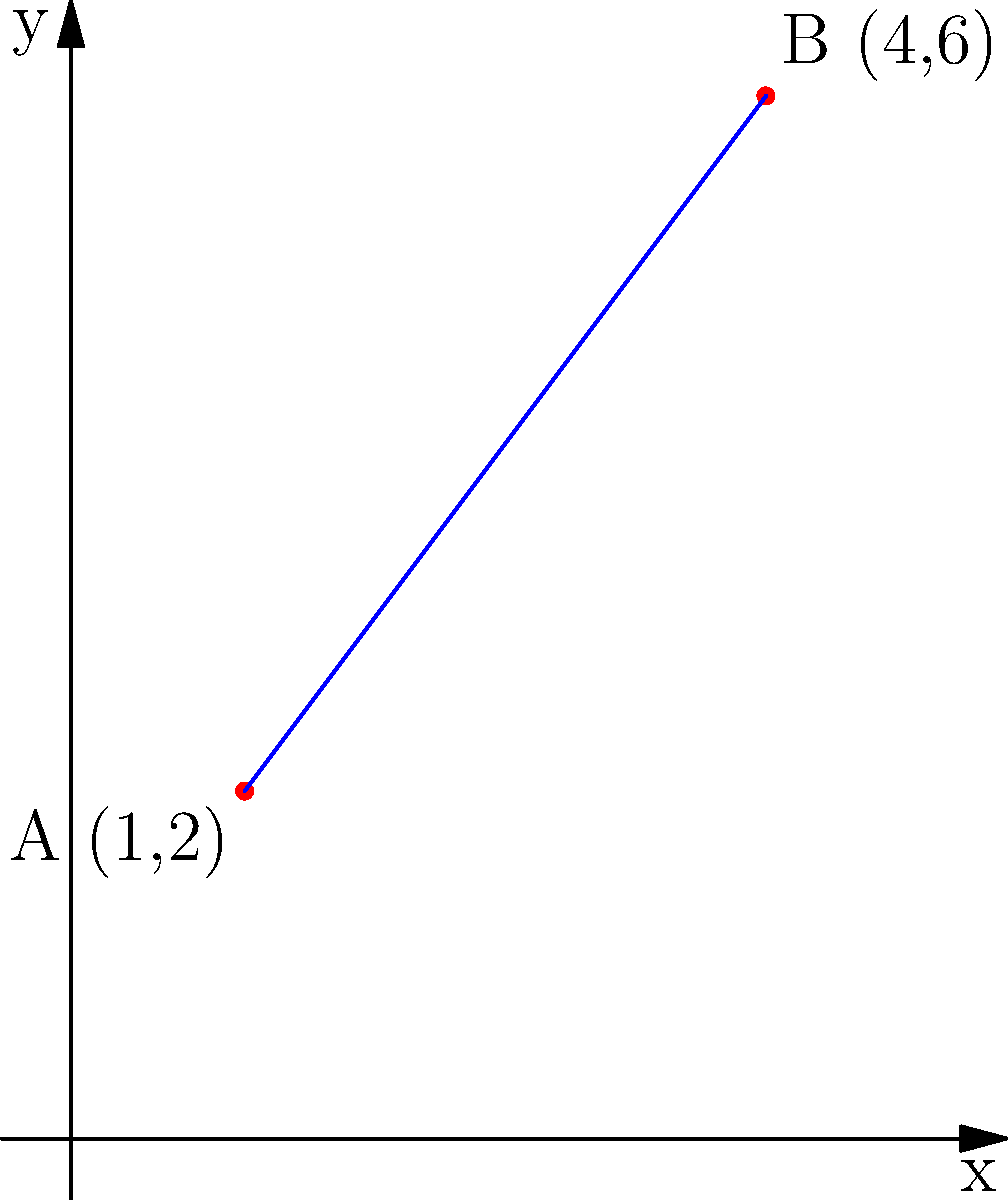In a network security analysis, two nodes A and B are identified at coordinates (1,2) and (4,6) respectively. Calculate the shortest distance between these nodes to assess potential vulnerabilities in the network topology. Round your answer to two decimal places. To find the distance between two points in a 2D plane, we use the distance formula derived from the Pythagorean theorem:

$$d = \sqrt{(x_2 - x_1)^2 + (y_2 - y_1)^2}$$

Where $(x_1, y_1)$ are the coordinates of the first point and $(x_2, y_2)$ are the coordinates of the second point.

Given:
- Point A: $(x_1, y_1) = (1, 2)$
- Point B: $(x_2, y_2) = (4, 6)$

Step 1: Substitute the values into the distance formula:
$$d = \sqrt{(4 - 1)^2 + (6 - 2)^2}$$

Step 2: Simplify the expressions inside the parentheses:
$$d = \sqrt{3^2 + 4^2}$$

Step 3: Calculate the squares:
$$d = \sqrt{9 + 16}$$

Step 4: Add the values under the square root:
$$d = \sqrt{25}$$

Step 5: Calculate the square root:
$$d = 5$$

The exact distance between the two nodes is 5 units. Since the question asks for the answer rounded to two decimal places, the final answer is 5.00.
Answer: 5.00 units 